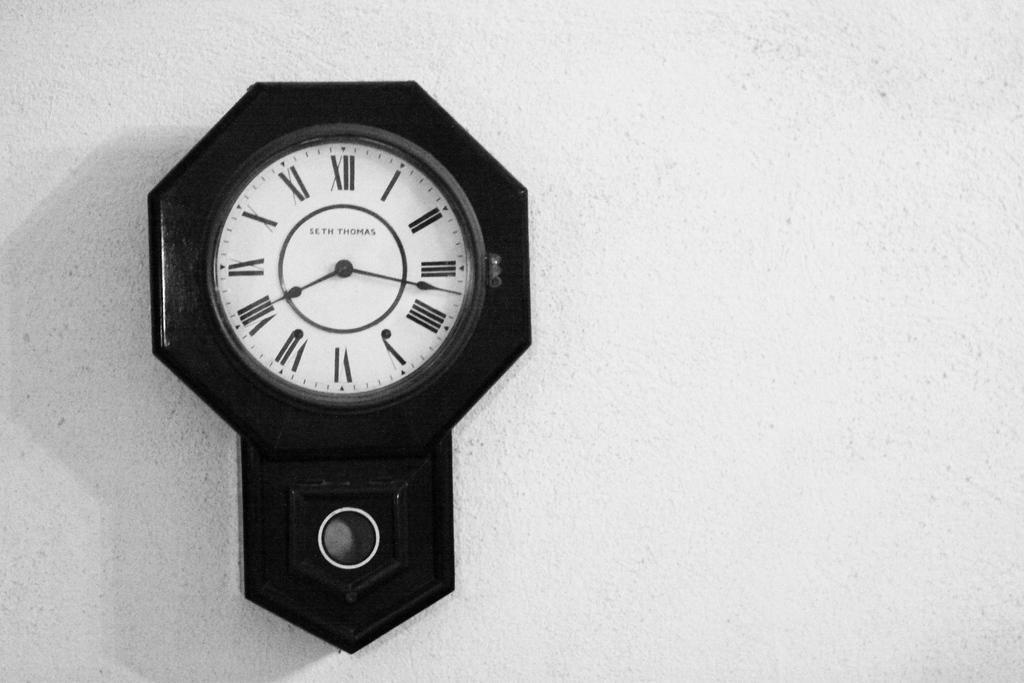How would you summarize this image in a sentence or two? In this image I can see the clock to the wall. I can see the clock is in white and black color. 